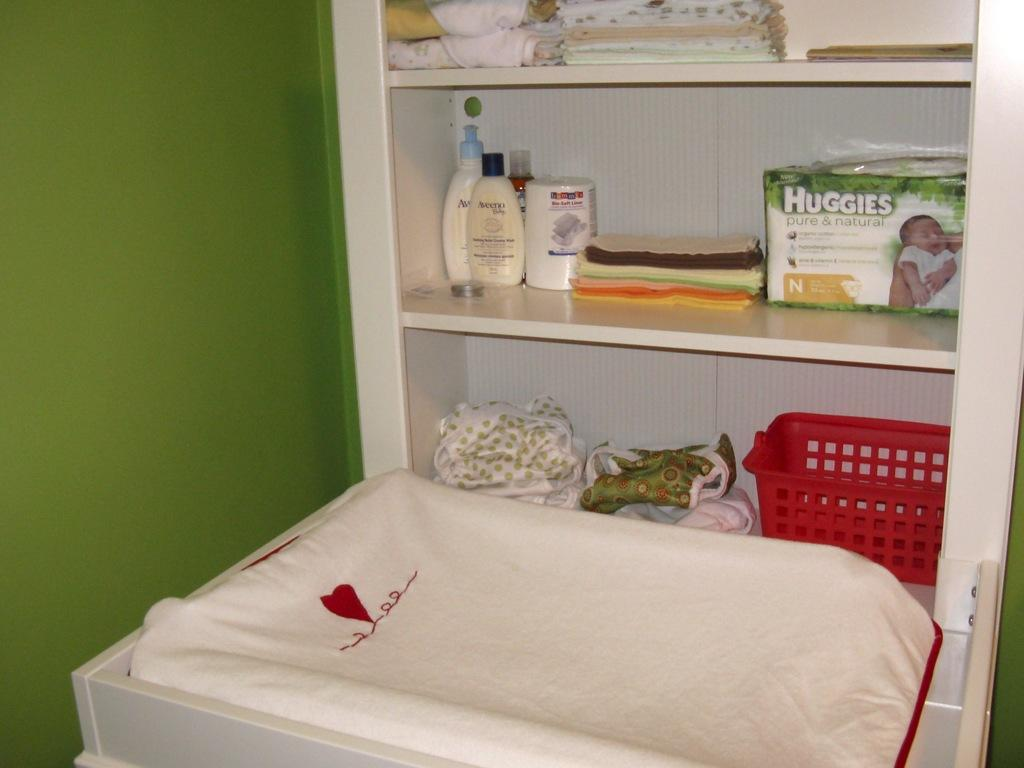<image>
Describe the image concisely. A changing table next to a shelf that has Huggies and Aveeno lotion. 